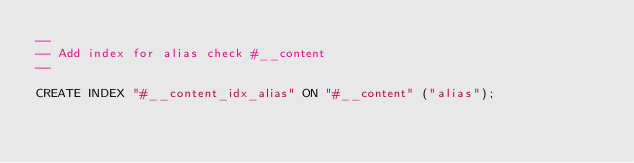Convert code to text. <code><loc_0><loc_0><loc_500><loc_500><_SQL_>--
-- Add index for alias check #__content
--

CREATE INDEX "#__content_idx_alias" ON "#__content" ("alias");
</code> 